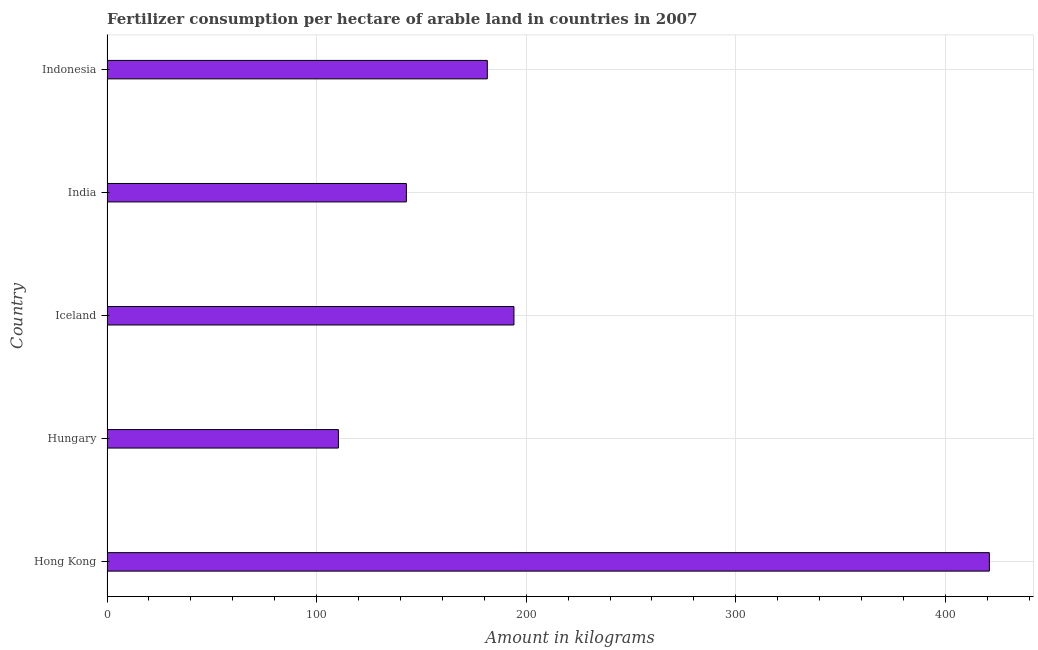Does the graph contain grids?
Provide a short and direct response. Yes. What is the title of the graph?
Make the answer very short. Fertilizer consumption per hectare of arable land in countries in 2007 . What is the label or title of the X-axis?
Offer a terse response. Amount in kilograms. What is the label or title of the Y-axis?
Make the answer very short. Country. What is the amount of fertilizer consumption in Iceland?
Your answer should be very brief. 194.17. Across all countries, what is the maximum amount of fertilizer consumption?
Ensure brevity in your answer.  421. Across all countries, what is the minimum amount of fertilizer consumption?
Ensure brevity in your answer.  110.41. In which country was the amount of fertilizer consumption maximum?
Ensure brevity in your answer.  Hong Kong. In which country was the amount of fertilizer consumption minimum?
Provide a short and direct response. Hungary. What is the sum of the amount of fertilizer consumption?
Provide a short and direct response. 1049.87. What is the difference between the amount of fertilizer consumption in Hungary and Iceland?
Provide a short and direct response. -83.76. What is the average amount of fertilizer consumption per country?
Your response must be concise. 209.97. What is the median amount of fertilizer consumption?
Your answer should be compact. 181.46. In how many countries, is the amount of fertilizer consumption greater than 360 kg?
Your answer should be compact. 1. What is the ratio of the amount of fertilizer consumption in Iceland to that in India?
Offer a very short reply. 1.36. Is the amount of fertilizer consumption in Hong Kong less than that in Iceland?
Give a very brief answer. No. Is the difference between the amount of fertilizer consumption in Hungary and Iceland greater than the difference between any two countries?
Your answer should be compact. No. What is the difference between the highest and the second highest amount of fertilizer consumption?
Ensure brevity in your answer.  226.83. What is the difference between the highest and the lowest amount of fertilizer consumption?
Ensure brevity in your answer.  310.59. Are all the bars in the graph horizontal?
Provide a short and direct response. Yes. How many countries are there in the graph?
Provide a short and direct response. 5. Are the values on the major ticks of X-axis written in scientific E-notation?
Make the answer very short. No. What is the Amount in kilograms of Hong Kong?
Keep it short and to the point. 421. What is the Amount in kilograms of Hungary?
Your answer should be very brief. 110.41. What is the Amount in kilograms of Iceland?
Make the answer very short. 194.17. What is the Amount in kilograms of India?
Make the answer very short. 142.84. What is the Amount in kilograms of Indonesia?
Offer a terse response. 181.46. What is the difference between the Amount in kilograms in Hong Kong and Hungary?
Your answer should be compact. 310.59. What is the difference between the Amount in kilograms in Hong Kong and Iceland?
Offer a terse response. 226.83. What is the difference between the Amount in kilograms in Hong Kong and India?
Your answer should be very brief. 278.16. What is the difference between the Amount in kilograms in Hong Kong and Indonesia?
Provide a short and direct response. 239.54. What is the difference between the Amount in kilograms in Hungary and Iceland?
Offer a very short reply. -83.76. What is the difference between the Amount in kilograms in Hungary and India?
Make the answer very short. -32.43. What is the difference between the Amount in kilograms in Hungary and Indonesia?
Your answer should be very brief. -71.05. What is the difference between the Amount in kilograms in Iceland and India?
Offer a very short reply. 51.33. What is the difference between the Amount in kilograms in Iceland and Indonesia?
Offer a very short reply. 12.71. What is the difference between the Amount in kilograms in India and Indonesia?
Ensure brevity in your answer.  -38.62. What is the ratio of the Amount in kilograms in Hong Kong to that in Hungary?
Provide a short and direct response. 3.81. What is the ratio of the Amount in kilograms in Hong Kong to that in Iceland?
Your response must be concise. 2.17. What is the ratio of the Amount in kilograms in Hong Kong to that in India?
Make the answer very short. 2.95. What is the ratio of the Amount in kilograms in Hong Kong to that in Indonesia?
Give a very brief answer. 2.32. What is the ratio of the Amount in kilograms in Hungary to that in Iceland?
Your answer should be very brief. 0.57. What is the ratio of the Amount in kilograms in Hungary to that in India?
Ensure brevity in your answer.  0.77. What is the ratio of the Amount in kilograms in Hungary to that in Indonesia?
Keep it short and to the point. 0.61. What is the ratio of the Amount in kilograms in Iceland to that in India?
Ensure brevity in your answer.  1.36. What is the ratio of the Amount in kilograms in Iceland to that in Indonesia?
Ensure brevity in your answer.  1.07. What is the ratio of the Amount in kilograms in India to that in Indonesia?
Make the answer very short. 0.79. 